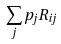<formula> <loc_0><loc_0><loc_500><loc_500>\sum _ { j } p _ { j } R _ { i j }</formula> 